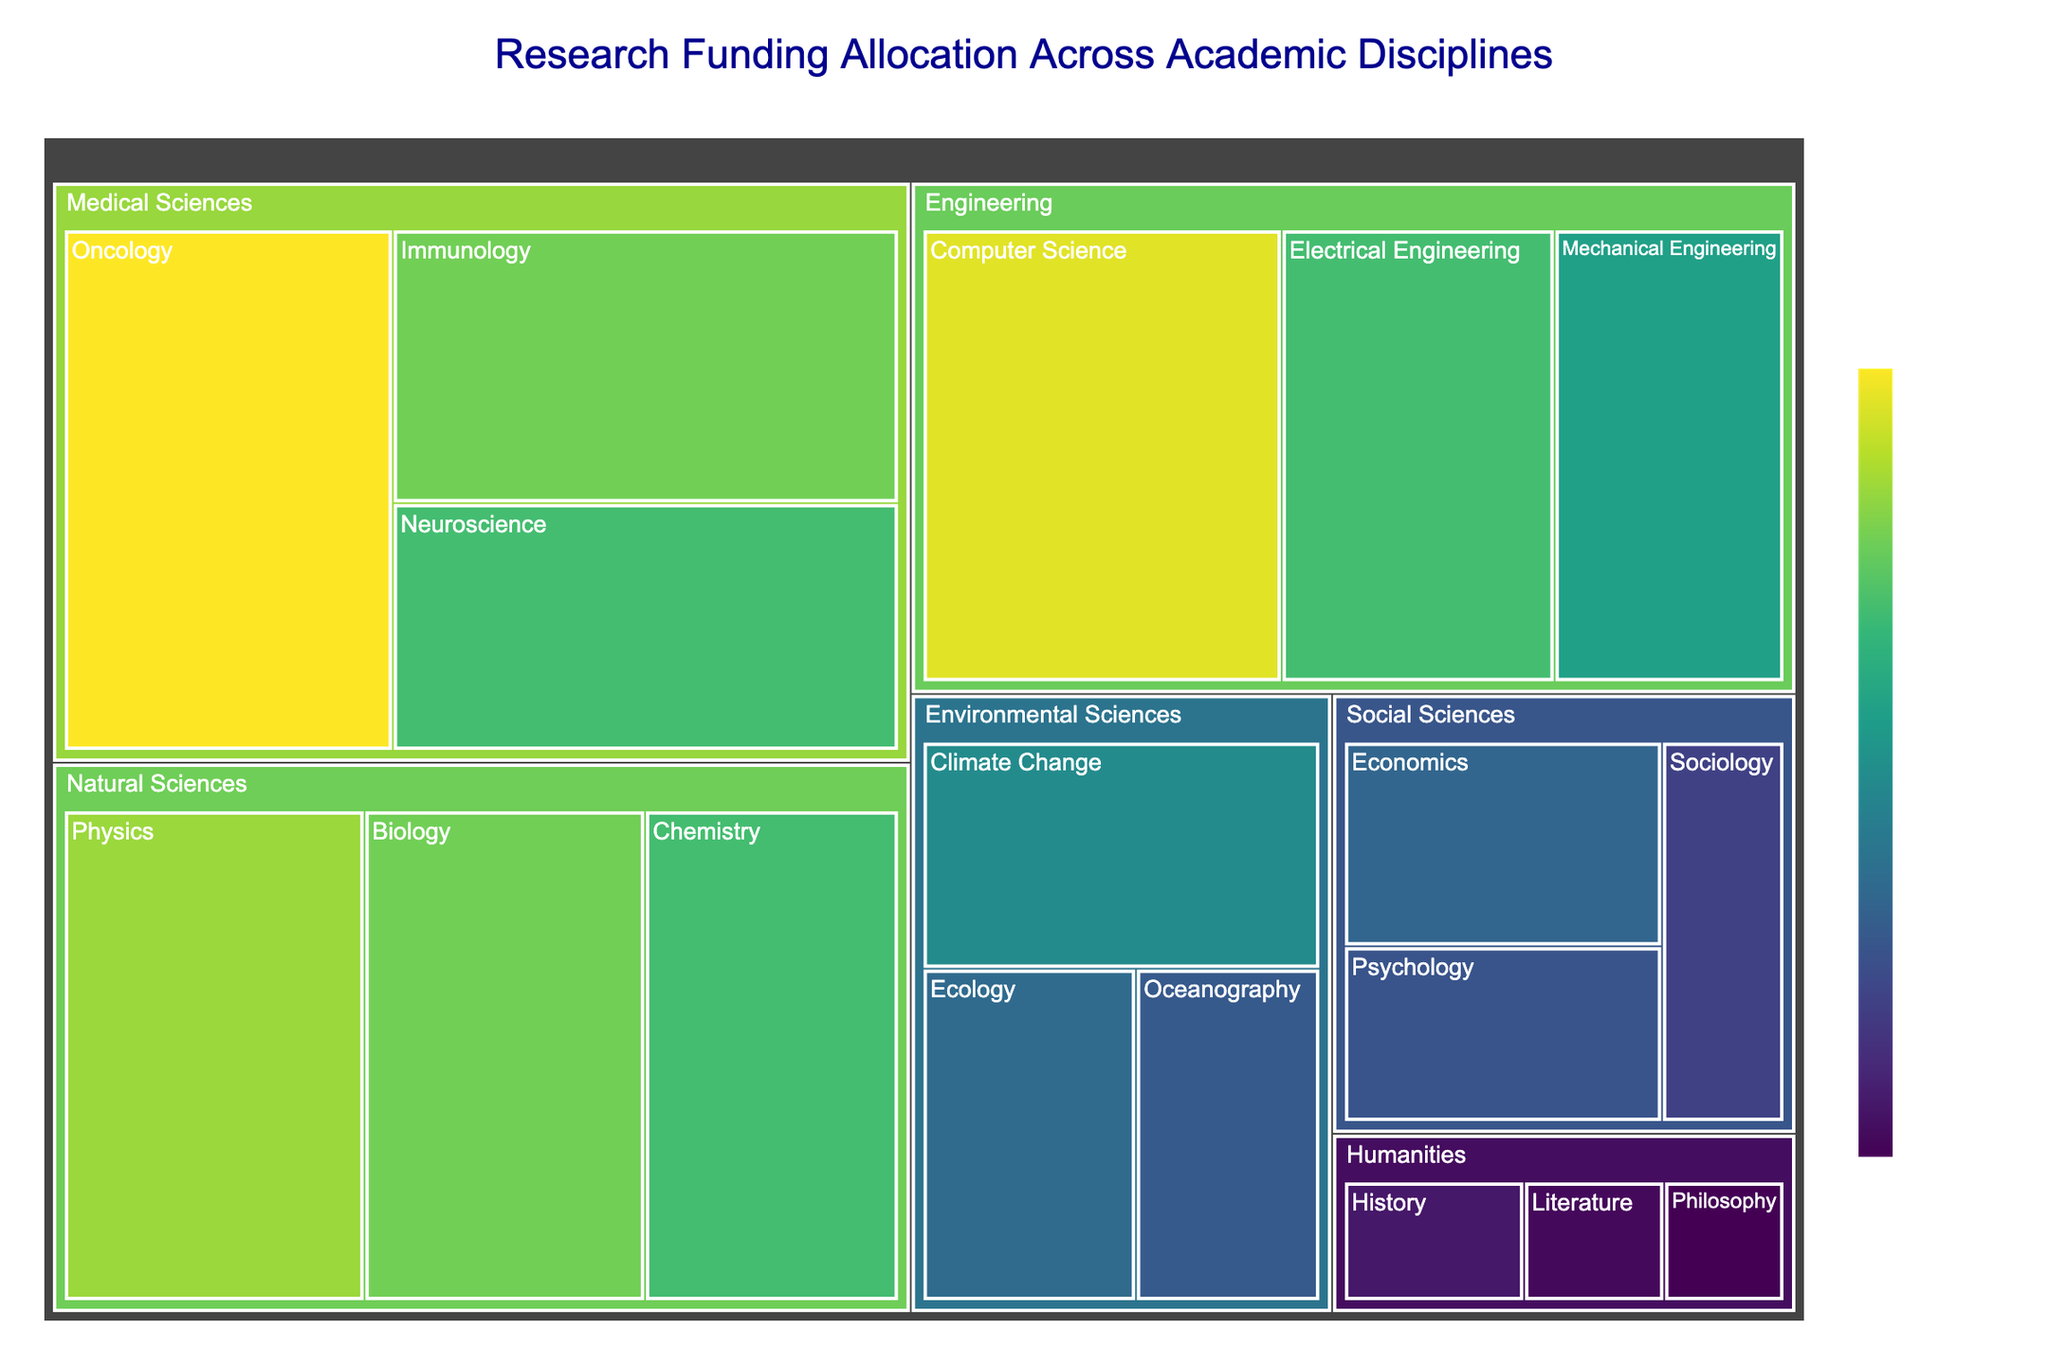What's the total funding for Natural Sciences? To find the total funding for Natural Sciences, sum the funding values for its subcategories: Physics ($450 million), Chemistry ($380 million), and Biology ($420 million). The total is 450 + 380 + 420 = 1250 million USD.
Answer: 1250 million USD Which subcategory in Engineering received the highest funding? Look at the subcategories under Engineering and identify the one with the largest funding value. Among Computer Science ($500 million), Electrical Engineering ($380 million), and Mechanical Engineering ($320 million), Computer Science received the highest funding.
Answer: Computer Science How does the funding for Philosophy compare to that of Literature? Locate the funding for Philosophy ($60 million) and Literature ($70 million) under the Humanities category. Literature has received more funding than Philosophy.
Answer: Literature received more funding than Philosophy What's the average funding for subcategories under Medical Sciences? To find the average funding for subcategories in Medical Sciences, add the funding values for Neuroscience ($380 million), Oncology ($520 million), and Immunology ($420 million), and divide by the number of subcategories: (380 + 520 + 420) / 3 = 440 million USD.
Answer: 440 million USD Which academic discipline has the highest total funding? Sum the funding for all subcategories in each category, then compare their totals. Natural Sciences: 1250 million, Social Sciences: 540 million, Engineering: 1200 million, Humanities: 220 million, Medical Sciences: 1320 million, Environmental Sciences: 690 million. Medical Sciences has the highest total funding.
Answer: Medical Sciences Is the funding for Oncology greater than the combined funding for Sociology and Psychology? Compare the funding for Oncology ($520 million) with the sum of funding for Sociology ($150 million) and Psychology ($180 million). Combined Sociology and Psychology: 150 + 180 = 330 million, which is less than 520 million. Oncology has higher funding.
Answer: Yes What's the difference in funding between Climate Change and Oceanography? Look at the funding values for Climate Change ($280 million) and Oceanography ($190 million). The difference is 280 - 190 = 90 million USD.
Answer: 90 million USD How much more funding does Computer Science receive compared to Sociology? Compare the funding for Computer Science ($500 million) and Sociology ($150 million). The difference is 500 - 150 = 350 million USD.
Answer: 350 million USD Which discipline has the largest funding disparity among its subcategories? Compare the disparities within each discipline by subtracting the smallest subcategory funding from the largest in each group. Natural Sciences: 450-380=70, Social Sciences: 210-150=60, Engineering: 500-320=180, Humanities: 90-60=30, Medical Sciences: 520-380=140, Environmental Sciences: 280-190=90. Engineering has the largest disparity.
Answer: Engineering 